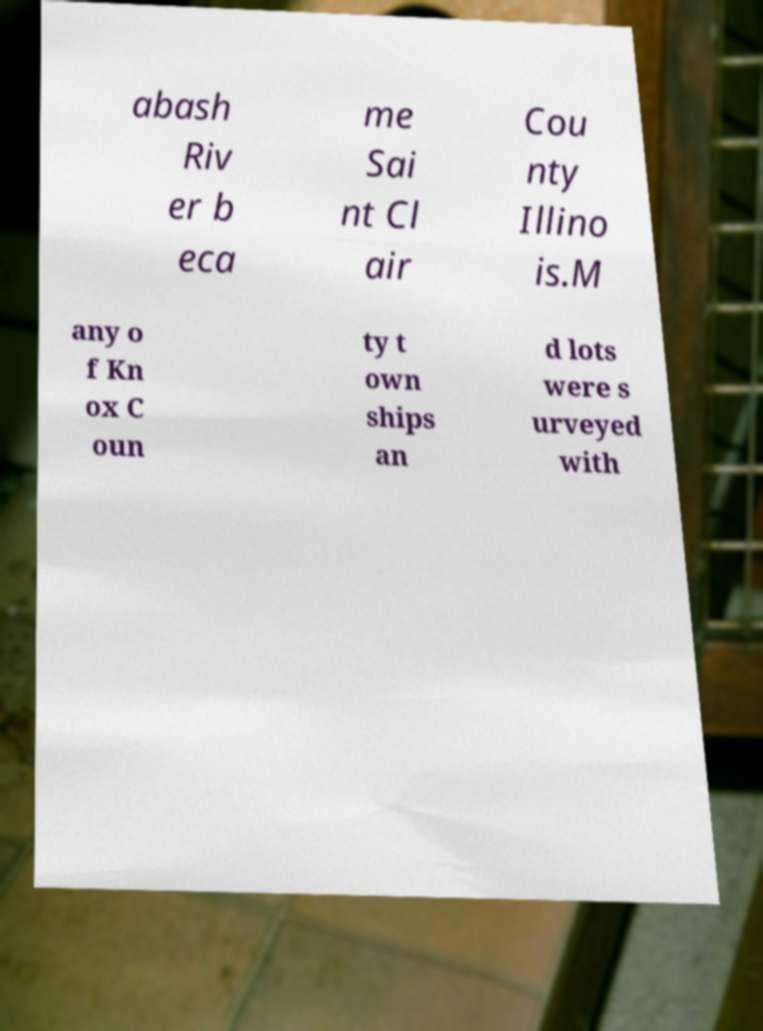For documentation purposes, I need the text within this image transcribed. Could you provide that? abash Riv er b eca me Sai nt Cl air Cou nty Illino is.M any o f Kn ox C oun ty t own ships an d lots were s urveyed with 